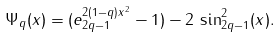Convert formula to latex. <formula><loc_0><loc_0><loc_500><loc_500>\Psi _ { q } ( x ) = ( e _ { 2 q - 1 } ^ { 2 ( 1 - q ) x ^ { 2 } } - 1 ) - 2 \, \sin _ { 2 q - 1 } ^ { 2 } ( x ) .</formula> 